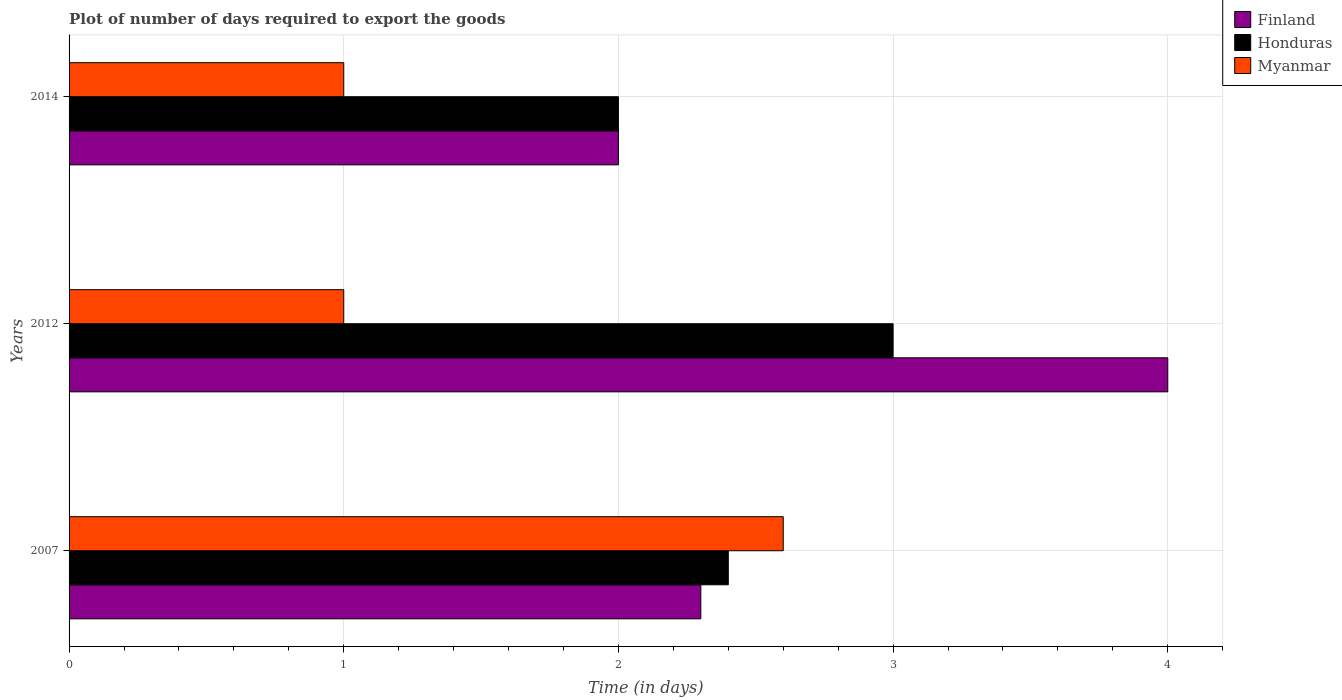How many different coloured bars are there?
Your answer should be very brief. 3. How many groups of bars are there?
Give a very brief answer. 3. How many bars are there on the 3rd tick from the top?
Ensure brevity in your answer.  3. What is the label of the 2nd group of bars from the top?
Provide a short and direct response. 2012. In how many cases, is the number of bars for a given year not equal to the number of legend labels?
Your answer should be compact. 0. What is the time required to export goods in Finland in 2014?
Make the answer very short. 2. Across all years, what is the maximum time required to export goods in Finland?
Your response must be concise. 4. Across all years, what is the minimum time required to export goods in Myanmar?
Make the answer very short. 1. In which year was the time required to export goods in Myanmar minimum?
Make the answer very short. 2012. What is the total time required to export goods in Finland in the graph?
Offer a terse response. 8.3. What is the difference between the time required to export goods in Finland in 2012 and that in 2014?
Ensure brevity in your answer.  2. What is the average time required to export goods in Honduras per year?
Your answer should be very brief. 2.47. In the year 2007, what is the difference between the time required to export goods in Finland and time required to export goods in Honduras?
Offer a terse response. -0.1. In how many years, is the time required to export goods in Myanmar greater than 0.2 days?
Give a very brief answer. 3. Is the time required to export goods in Honduras in 2007 less than that in 2014?
Your response must be concise. No. What is the difference between the highest and the second highest time required to export goods in Honduras?
Provide a short and direct response. 0.6. What is the difference between the highest and the lowest time required to export goods in Honduras?
Provide a short and direct response. 1. Is the sum of the time required to export goods in Myanmar in 2007 and 2014 greater than the maximum time required to export goods in Finland across all years?
Offer a terse response. No. What does the 3rd bar from the bottom in 2007 represents?
Keep it short and to the point. Myanmar. Are the values on the major ticks of X-axis written in scientific E-notation?
Ensure brevity in your answer.  No. Does the graph contain any zero values?
Offer a very short reply. No. How many legend labels are there?
Your answer should be very brief. 3. How are the legend labels stacked?
Give a very brief answer. Vertical. What is the title of the graph?
Provide a succinct answer. Plot of number of days required to export the goods. Does "Sierra Leone" appear as one of the legend labels in the graph?
Ensure brevity in your answer.  No. What is the label or title of the X-axis?
Your answer should be very brief. Time (in days). What is the Time (in days) in Finland in 2007?
Your response must be concise. 2.3. What is the Time (in days) of Honduras in 2012?
Provide a short and direct response. 3. What is the Time (in days) in Myanmar in 2012?
Ensure brevity in your answer.  1. What is the Time (in days) in Myanmar in 2014?
Make the answer very short. 1. Across all years, what is the maximum Time (in days) in Honduras?
Provide a short and direct response. 3. Across all years, what is the maximum Time (in days) of Myanmar?
Keep it short and to the point. 2.6. What is the total Time (in days) in Finland in the graph?
Make the answer very short. 8.3. What is the total Time (in days) of Honduras in the graph?
Offer a terse response. 7.4. What is the difference between the Time (in days) in Honduras in 2007 and that in 2012?
Your response must be concise. -0.6. What is the difference between the Time (in days) in Myanmar in 2007 and that in 2012?
Provide a succinct answer. 1.6. What is the difference between the Time (in days) in Finland in 2007 and that in 2014?
Offer a terse response. 0.3. What is the difference between the Time (in days) of Myanmar in 2007 and that in 2014?
Make the answer very short. 1.6. What is the difference between the Time (in days) in Finland in 2012 and that in 2014?
Give a very brief answer. 2. What is the difference between the Time (in days) of Myanmar in 2012 and that in 2014?
Your answer should be compact. 0. What is the difference between the Time (in days) of Finland in 2007 and the Time (in days) of Honduras in 2012?
Provide a short and direct response. -0.7. What is the difference between the Time (in days) of Finland in 2007 and the Time (in days) of Myanmar in 2012?
Your answer should be very brief. 1.3. What is the difference between the Time (in days) in Finland in 2007 and the Time (in days) in Honduras in 2014?
Your answer should be very brief. 0.3. What is the difference between the Time (in days) in Finland in 2012 and the Time (in days) in Honduras in 2014?
Make the answer very short. 2. What is the average Time (in days) of Finland per year?
Provide a succinct answer. 2.77. What is the average Time (in days) of Honduras per year?
Ensure brevity in your answer.  2.47. What is the average Time (in days) in Myanmar per year?
Your response must be concise. 1.53. In the year 2007, what is the difference between the Time (in days) in Finland and Time (in days) in Myanmar?
Provide a short and direct response. -0.3. In the year 2007, what is the difference between the Time (in days) of Honduras and Time (in days) of Myanmar?
Provide a short and direct response. -0.2. In the year 2012, what is the difference between the Time (in days) in Finland and Time (in days) in Honduras?
Your answer should be very brief. 1. In the year 2014, what is the difference between the Time (in days) of Finland and Time (in days) of Honduras?
Give a very brief answer. 0. In the year 2014, what is the difference between the Time (in days) in Finland and Time (in days) in Myanmar?
Your answer should be very brief. 1. In the year 2014, what is the difference between the Time (in days) of Honduras and Time (in days) of Myanmar?
Keep it short and to the point. 1. What is the ratio of the Time (in days) in Finland in 2007 to that in 2012?
Provide a succinct answer. 0.57. What is the ratio of the Time (in days) of Honduras in 2007 to that in 2012?
Your answer should be compact. 0.8. What is the ratio of the Time (in days) of Finland in 2007 to that in 2014?
Your answer should be very brief. 1.15. What is the ratio of the Time (in days) in Honduras in 2012 to that in 2014?
Keep it short and to the point. 1.5. What is the ratio of the Time (in days) of Myanmar in 2012 to that in 2014?
Offer a terse response. 1. What is the difference between the highest and the second highest Time (in days) in Honduras?
Keep it short and to the point. 0.6. What is the difference between the highest and the second highest Time (in days) in Myanmar?
Provide a short and direct response. 1.6. What is the difference between the highest and the lowest Time (in days) of Finland?
Your answer should be compact. 2. What is the difference between the highest and the lowest Time (in days) of Honduras?
Your answer should be very brief. 1. 